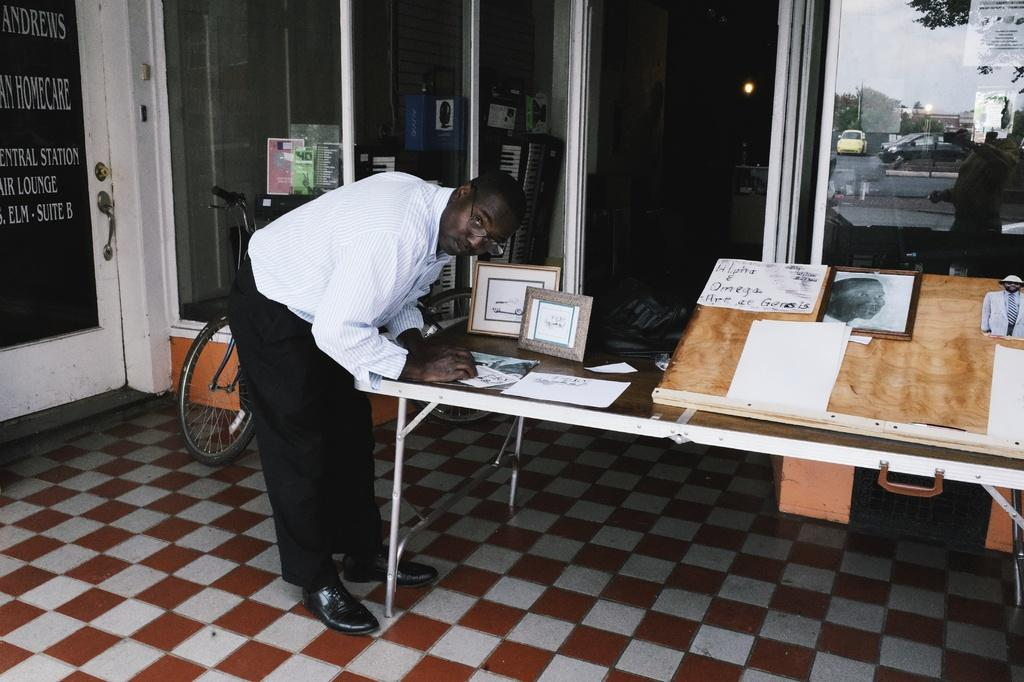What is the position of the person in the image? There is a person standing on the left side of the image. What is the person doing in the image? The person is looking at something. What can be seen in the background of the image? There is a bicycle, a glass door, and a car in the background of the image. What type of vegetation is on the right side of the image? There is a tree on the right side of the image. What type of organization is the person affiliated with in the image? There is no information about the person's affiliation or any organization in the image. 